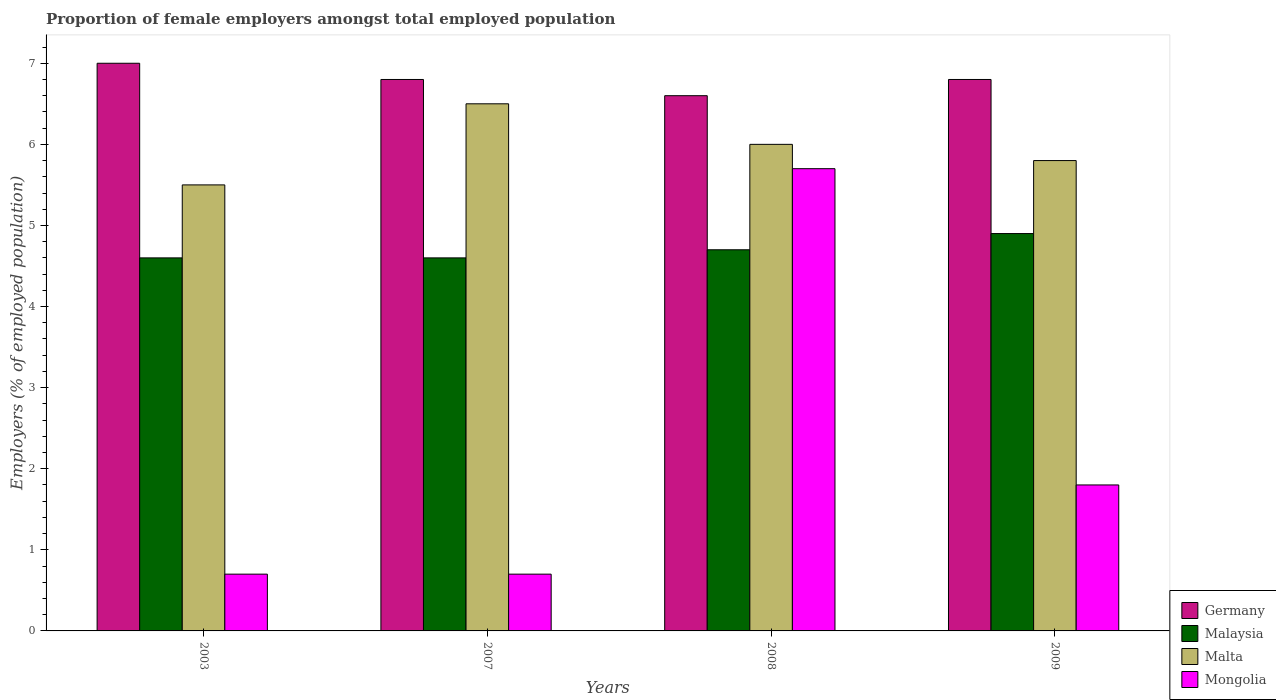How many bars are there on the 2nd tick from the left?
Give a very brief answer. 4. How many bars are there on the 3rd tick from the right?
Your answer should be very brief. 4. What is the label of the 3rd group of bars from the left?
Your answer should be very brief. 2008. In how many cases, is the number of bars for a given year not equal to the number of legend labels?
Keep it short and to the point. 0. What is the proportion of female employers in Mongolia in 2003?
Make the answer very short. 0.7. Across all years, what is the maximum proportion of female employers in Germany?
Keep it short and to the point. 7. Across all years, what is the minimum proportion of female employers in Malaysia?
Provide a short and direct response. 4.6. In which year was the proportion of female employers in Germany maximum?
Your answer should be compact. 2003. What is the total proportion of female employers in Germany in the graph?
Keep it short and to the point. 27.2. What is the difference between the proportion of female employers in Malaysia in 2003 and that in 2008?
Provide a short and direct response. -0.1. What is the difference between the proportion of female employers in Germany in 2008 and the proportion of female employers in Malta in 2009?
Your response must be concise. 0.8. What is the average proportion of female employers in Malta per year?
Provide a succinct answer. 5.95. In the year 2003, what is the difference between the proportion of female employers in Malaysia and proportion of female employers in Mongolia?
Provide a short and direct response. 3.9. What is the ratio of the proportion of female employers in Malaysia in 2003 to that in 2008?
Your answer should be very brief. 0.98. Is the proportion of female employers in Malta in 2003 less than that in 2008?
Your response must be concise. Yes. Is the difference between the proportion of female employers in Malaysia in 2008 and 2009 greater than the difference between the proportion of female employers in Mongolia in 2008 and 2009?
Your answer should be compact. No. In how many years, is the proportion of female employers in Malta greater than the average proportion of female employers in Malta taken over all years?
Your answer should be compact. 2. What does the 3rd bar from the left in 2003 represents?
Keep it short and to the point. Malta. What does the 1st bar from the right in 2007 represents?
Your answer should be compact. Mongolia. Is it the case that in every year, the sum of the proportion of female employers in Mongolia and proportion of female employers in Malaysia is greater than the proportion of female employers in Malta?
Offer a terse response. No. Are all the bars in the graph horizontal?
Ensure brevity in your answer.  No. What is the difference between two consecutive major ticks on the Y-axis?
Ensure brevity in your answer.  1. Are the values on the major ticks of Y-axis written in scientific E-notation?
Ensure brevity in your answer.  No. Where does the legend appear in the graph?
Ensure brevity in your answer.  Bottom right. What is the title of the graph?
Your answer should be compact. Proportion of female employers amongst total employed population. Does "Swaziland" appear as one of the legend labels in the graph?
Provide a succinct answer. No. What is the label or title of the X-axis?
Keep it short and to the point. Years. What is the label or title of the Y-axis?
Make the answer very short. Employers (% of employed population). What is the Employers (% of employed population) of Malaysia in 2003?
Your response must be concise. 4.6. What is the Employers (% of employed population) of Mongolia in 2003?
Keep it short and to the point. 0.7. What is the Employers (% of employed population) of Germany in 2007?
Provide a succinct answer. 6.8. What is the Employers (% of employed population) in Malaysia in 2007?
Provide a short and direct response. 4.6. What is the Employers (% of employed population) in Mongolia in 2007?
Offer a terse response. 0.7. What is the Employers (% of employed population) of Germany in 2008?
Offer a very short reply. 6.6. What is the Employers (% of employed population) in Malaysia in 2008?
Your answer should be compact. 4.7. What is the Employers (% of employed population) of Mongolia in 2008?
Your answer should be compact. 5.7. What is the Employers (% of employed population) of Germany in 2009?
Your response must be concise. 6.8. What is the Employers (% of employed population) in Malaysia in 2009?
Offer a very short reply. 4.9. What is the Employers (% of employed population) in Malta in 2009?
Provide a succinct answer. 5.8. What is the Employers (% of employed population) of Mongolia in 2009?
Make the answer very short. 1.8. Across all years, what is the maximum Employers (% of employed population) of Malaysia?
Provide a succinct answer. 4.9. Across all years, what is the maximum Employers (% of employed population) of Mongolia?
Offer a very short reply. 5.7. Across all years, what is the minimum Employers (% of employed population) in Germany?
Give a very brief answer. 6.6. Across all years, what is the minimum Employers (% of employed population) of Malaysia?
Your response must be concise. 4.6. Across all years, what is the minimum Employers (% of employed population) in Mongolia?
Ensure brevity in your answer.  0.7. What is the total Employers (% of employed population) of Germany in the graph?
Provide a succinct answer. 27.2. What is the total Employers (% of employed population) in Malta in the graph?
Your answer should be very brief. 23.8. What is the difference between the Employers (% of employed population) in Malaysia in 2003 and that in 2007?
Your answer should be compact. 0. What is the difference between the Employers (% of employed population) in Malta in 2003 and that in 2007?
Make the answer very short. -1. What is the difference between the Employers (% of employed population) in Germany in 2003 and that in 2008?
Your answer should be compact. 0.4. What is the difference between the Employers (% of employed population) of Malaysia in 2007 and that in 2008?
Keep it short and to the point. -0.1. What is the difference between the Employers (% of employed population) in Germany in 2007 and that in 2009?
Provide a short and direct response. 0. What is the difference between the Employers (% of employed population) of Malaysia in 2007 and that in 2009?
Your answer should be very brief. -0.3. What is the difference between the Employers (% of employed population) in Malta in 2007 and that in 2009?
Offer a terse response. 0.7. What is the difference between the Employers (% of employed population) in Germany in 2008 and that in 2009?
Your answer should be compact. -0.2. What is the difference between the Employers (% of employed population) in Germany in 2003 and the Employers (% of employed population) in Malta in 2007?
Make the answer very short. 0.5. What is the difference between the Employers (% of employed population) of Germany in 2003 and the Employers (% of employed population) of Mongolia in 2007?
Make the answer very short. 6.3. What is the difference between the Employers (% of employed population) of Malaysia in 2003 and the Employers (% of employed population) of Mongolia in 2007?
Provide a short and direct response. 3.9. What is the difference between the Employers (% of employed population) of Germany in 2003 and the Employers (% of employed population) of Malaysia in 2008?
Ensure brevity in your answer.  2.3. What is the difference between the Employers (% of employed population) of Malaysia in 2003 and the Employers (% of employed population) of Malta in 2008?
Offer a very short reply. -1.4. What is the difference between the Employers (% of employed population) in Malaysia in 2003 and the Employers (% of employed population) in Mongolia in 2008?
Keep it short and to the point. -1.1. What is the difference between the Employers (% of employed population) of Germany in 2003 and the Employers (% of employed population) of Malaysia in 2009?
Your answer should be compact. 2.1. What is the difference between the Employers (% of employed population) of Germany in 2003 and the Employers (% of employed population) of Mongolia in 2009?
Provide a short and direct response. 5.2. What is the difference between the Employers (% of employed population) of Malta in 2003 and the Employers (% of employed population) of Mongolia in 2009?
Provide a short and direct response. 3.7. What is the difference between the Employers (% of employed population) in Malaysia in 2007 and the Employers (% of employed population) in Mongolia in 2008?
Offer a terse response. -1.1. What is the difference between the Employers (% of employed population) in Malta in 2007 and the Employers (% of employed population) in Mongolia in 2008?
Your answer should be very brief. 0.8. What is the difference between the Employers (% of employed population) in Germany in 2007 and the Employers (% of employed population) in Malaysia in 2009?
Keep it short and to the point. 1.9. What is the difference between the Employers (% of employed population) in Malaysia in 2007 and the Employers (% of employed population) in Malta in 2009?
Provide a short and direct response. -1.2. What is the difference between the Employers (% of employed population) of Malta in 2007 and the Employers (% of employed population) of Mongolia in 2009?
Ensure brevity in your answer.  4.7. What is the difference between the Employers (% of employed population) of Germany in 2008 and the Employers (% of employed population) of Malta in 2009?
Ensure brevity in your answer.  0.8. What is the difference between the Employers (% of employed population) in Germany in 2008 and the Employers (% of employed population) in Mongolia in 2009?
Provide a succinct answer. 4.8. What is the difference between the Employers (% of employed population) in Malaysia in 2008 and the Employers (% of employed population) in Mongolia in 2009?
Your answer should be compact. 2.9. What is the difference between the Employers (% of employed population) of Malta in 2008 and the Employers (% of employed population) of Mongolia in 2009?
Ensure brevity in your answer.  4.2. What is the average Employers (% of employed population) in Germany per year?
Give a very brief answer. 6.8. What is the average Employers (% of employed population) of Malaysia per year?
Offer a very short reply. 4.7. What is the average Employers (% of employed population) of Malta per year?
Provide a succinct answer. 5.95. What is the average Employers (% of employed population) in Mongolia per year?
Provide a short and direct response. 2.23. In the year 2003, what is the difference between the Employers (% of employed population) of Germany and Employers (% of employed population) of Mongolia?
Provide a short and direct response. 6.3. In the year 2003, what is the difference between the Employers (% of employed population) in Malta and Employers (% of employed population) in Mongolia?
Make the answer very short. 4.8. In the year 2007, what is the difference between the Employers (% of employed population) of Germany and Employers (% of employed population) of Malaysia?
Give a very brief answer. 2.2. In the year 2007, what is the difference between the Employers (% of employed population) in Germany and Employers (% of employed population) in Mongolia?
Offer a terse response. 6.1. In the year 2007, what is the difference between the Employers (% of employed population) of Malaysia and Employers (% of employed population) of Mongolia?
Make the answer very short. 3.9. In the year 2008, what is the difference between the Employers (% of employed population) of Germany and Employers (% of employed population) of Malaysia?
Ensure brevity in your answer.  1.9. In the year 2008, what is the difference between the Employers (% of employed population) in Germany and Employers (% of employed population) in Mongolia?
Offer a terse response. 0.9. In the year 2008, what is the difference between the Employers (% of employed population) of Malaysia and Employers (% of employed population) of Mongolia?
Provide a succinct answer. -1. In the year 2009, what is the difference between the Employers (% of employed population) in Germany and Employers (% of employed population) in Mongolia?
Make the answer very short. 5. In the year 2009, what is the difference between the Employers (% of employed population) of Malaysia and Employers (% of employed population) of Malta?
Give a very brief answer. -0.9. What is the ratio of the Employers (% of employed population) of Germany in 2003 to that in 2007?
Your answer should be very brief. 1.03. What is the ratio of the Employers (% of employed population) of Malta in 2003 to that in 2007?
Your answer should be very brief. 0.85. What is the ratio of the Employers (% of employed population) of Germany in 2003 to that in 2008?
Your answer should be very brief. 1.06. What is the ratio of the Employers (% of employed population) of Malaysia in 2003 to that in 2008?
Ensure brevity in your answer.  0.98. What is the ratio of the Employers (% of employed population) in Mongolia in 2003 to that in 2008?
Your response must be concise. 0.12. What is the ratio of the Employers (% of employed population) in Germany in 2003 to that in 2009?
Ensure brevity in your answer.  1.03. What is the ratio of the Employers (% of employed population) of Malaysia in 2003 to that in 2009?
Your response must be concise. 0.94. What is the ratio of the Employers (% of employed population) of Malta in 2003 to that in 2009?
Make the answer very short. 0.95. What is the ratio of the Employers (% of employed population) of Mongolia in 2003 to that in 2009?
Keep it short and to the point. 0.39. What is the ratio of the Employers (% of employed population) of Germany in 2007 to that in 2008?
Provide a succinct answer. 1.03. What is the ratio of the Employers (% of employed population) of Malaysia in 2007 to that in 2008?
Provide a short and direct response. 0.98. What is the ratio of the Employers (% of employed population) of Mongolia in 2007 to that in 2008?
Your response must be concise. 0.12. What is the ratio of the Employers (% of employed population) of Germany in 2007 to that in 2009?
Keep it short and to the point. 1. What is the ratio of the Employers (% of employed population) of Malaysia in 2007 to that in 2009?
Keep it short and to the point. 0.94. What is the ratio of the Employers (% of employed population) in Malta in 2007 to that in 2009?
Provide a succinct answer. 1.12. What is the ratio of the Employers (% of employed population) of Mongolia in 2007 to that in 2009?
Offer a very short reply. 0.39. What is the ratio of the Employers (% of employed population) of Germany in 2008 to that in 2009?
Your response must be concise. 0.97. What is the ratio of the Employers (% of employed population) in Malaysia in 2008 to that in 2009?
Give a very brief answer. 0.96. What is the ratio of the Employers (% of employed population) of Malta in 2008 to that in 2009?
Make the answer very short. 1.03. What is the ratio of the Employers (% of employed population) in Mongolia in 2008 to that in 2009?
Ensure brevity in your answer.  3.17. What is the difference between the highest and the second highest Employers (% of employed population) in Malaysia?
Provide a succinct answer. 0.2. What is the difference between the highest and the second highest Employers (% of employed population) of Malta?
Ensure brevity in your answer.  0.5. What is the difference between the highest and the second highest Employers (% of employed population) in Mongolia?
Offer a very short reply. 3.9. What is the difference between the highest and the lowest Employers (% of employed population) of Malta?
Ensure brevity in your answer.  1. What is the difference between the highest and the lowest Employers (% of employed population) of Mongolia?
Offer a very short reply. 5. 